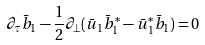Convert formula to latex. <formula><loc_0><loc_0><loc_500><loc_500>\partial _ { \tau } \bar { b } _ { 1 } - \frac { 1 } { 2 } \partial _ { \perp } ( \bar { u } _ { 1 } \bar { b } _ { 1 } ^ { * } - \bar { u } _ { 1 } ^ { * } \bar { b } _ { 1 } ) = 0</formula> 